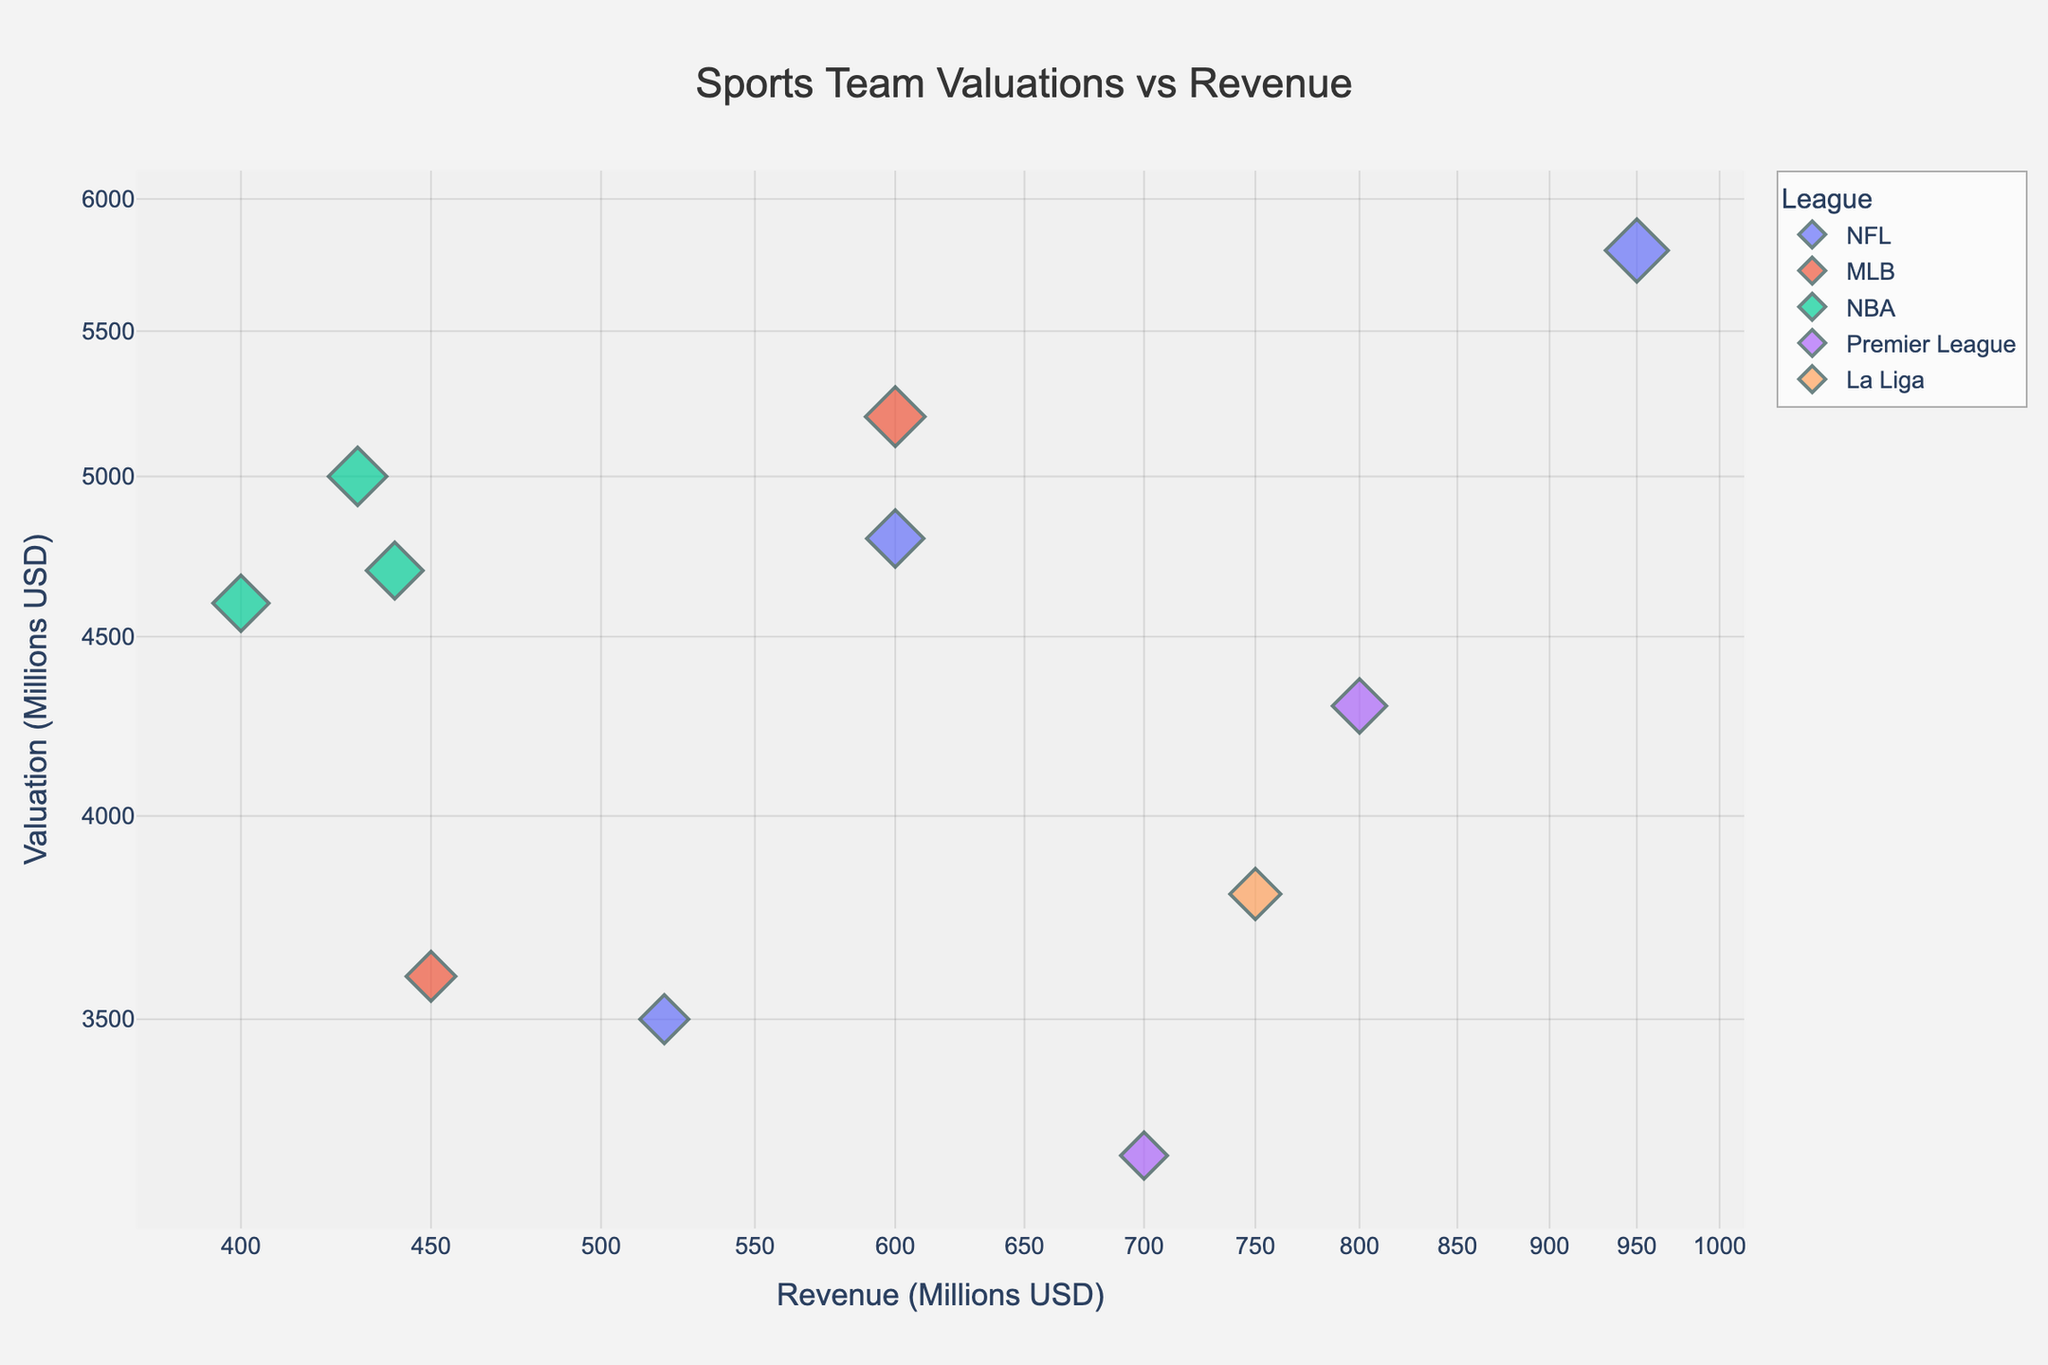What's the title of the figure? The title of the figure is written at the top, centered. It says ‘Sports Team Valuations vs Revenue’.
Answer: Sports Team Valuations vs Revenue How many data points are in the Premier League? Look for markers in the Premier League color (assuming it is consistent across the figure and in the legend) and count them. There are two: Manchester United and Liverpool.
Answer: 2 Which team has the highest revenue? Check the x-axis for the highest value and identify the team closest to that value. The highest revenue is 950 (in millions), which is for the Dallas Cowboys.
Answer: Dallas Cowboys What's the average valuation of NFL teams? Identify the teams in the NFL and find their valuations: Dallas Cowboys (5800), New England Patriots (4800), and Chicago Bears (3500). Sum these values and divide by the number of NFL teams. (5800 + 4800 + 3500) / 3 = 14000 / 3 ≈ 4666.67
Answer: 4666.67 Which league has the most teams plotted? Count the number of data points for each league. NFL (3 teams: Dallas Cowboys, New England Patriots, Chicago Bears), MLB (2 teams: New York Yankees, Boston Red Sox), NBA (3 teams: New York Knicks, Golden State Warriors, Los Angeles Lakers), Premier League (2 teams: Manchester United, Liverpool), La Liga (1 team: Real Madrid). NBA and NFL both have 3 teams each, the most.
Answer: NBA and NFL Which team has lower revenue, Golden State Warriors or Los Angeles Lakers? Compare the revenue values for Golden State Warriors (440) and Los Angeles Lakers (400) to see which one is lower.
Answer: Los Angeles Lakers Are there any teams with valuation greater than 4500 million but revenue less than 500 million? Check the scatter plot for any teams where the y-axis value (valuation) is above 4500 and the x-axis value (revenue) is below 500. New York Knicks (valuation: 5000, revenue: 430) and Los Angeles Lakers (valuation: 4600, revenue: 400) satisfy these conditions.
Answer: New York Knicks, Los Angeles Lakers What's the difference in valuation between the highest valued and the lowest valued teams? Identify the highest and lowest valuation values from the y-axis. The highest valuation is 5800 (Dallas Cowboys) and the lowest is 3200 (Liverpool). Calculate the difference: 5800 - 3200 = 2600.
Answer: 2600 Which team in the Premier League has higher valuation? Compare the valuations of the Premier League teams: Manchester United (4300) and Liverpool (3200).
Answer: Manchester United Does any team in the MLS appear on the plot? Look for any markers indicating MLS teams in the legend and verify their presence in the scatter plot. There are no MLS teams in the provided data and plot.
Answer: No 